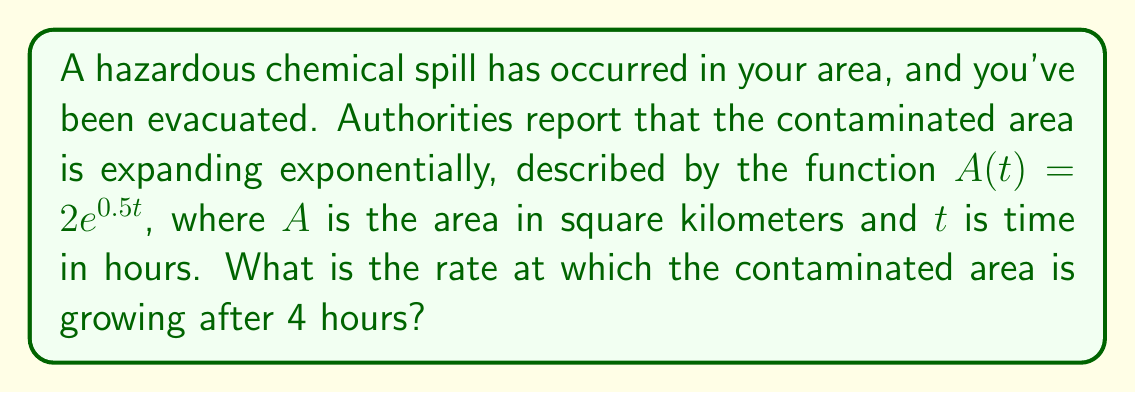Teach me how to tackle this problem. To find the rate at which the contaminated area is growing after 4 hours, we need to find the derivative of the function $A(t)$ and evaluate it at $t=4$. Let's follow these steps:

1) The given function is $A(t) = 2e^{0.5t}$

2) To find the derivative, we use the chain rule:
   $$\frac{d}{dt}[2e^{0.5t}] = 2 \cdot \frac{d}{dt}[e^{0.5t}] = 2 \cdot e^{0.5t} \cdot \frac{d}{dt}[0.5t] = 2 \cdot e^{0.5t} \cdot 0.5$$

3) Simplify:
   $$A'(t) = e^{0.5t}$$

4) This derivative represents the rate of change of the area with respect to time.

5) To find the rate after 4 hours, we evaluate $A'(4)$:
   $$A'(4) = e^{0.5 \cdot 4} = e^2 \approx 7.389$$

Therefore, after 4 hours, the contaminated area is growing at a rate of approximately 7.389 square kilometers per hour.
Answer: $e^2 \approx 7.389$ km²/hr 